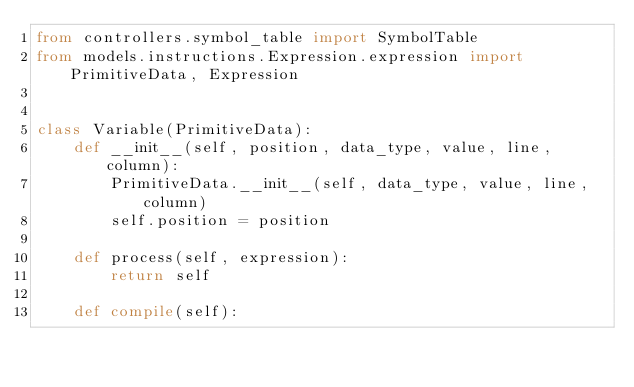Convert code to text. <code><loc_0><loc_0><loc_500><loc_500><_Python_>from controllers.symbol_table import SymbolTable
from models.instructions.Expression.expression import PrimitiveData, Expression


class Variable(PrimitiveData):
    def __init__(self, position, data_type, value, line, column):
        PrimitiveData.__init__(self, data_type, value, line, column)
        self.position = position
        
    def process(self, expression):
        return self
        
    def compile(self):</code> 